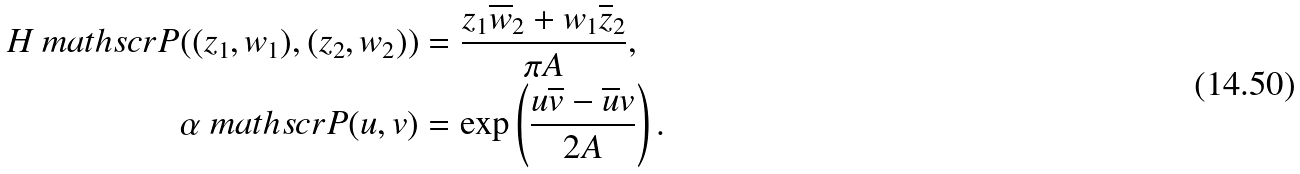<formula> <loc_0><loc_0><loc_500><loc_500>H _ { \ } m a t h s c r { P } ( ( z _ { 1 } , w _ { 1 } ) , ( z _ { 2 } , w _ { 2 } ) ) & = \frac { z _ { 1 } \overline { w } _ { 2 } + w _ { 1 } \overline { z } _ { 2 } } { \pi A } , \\ \alpha _ { \ } m a t h s c r { P } ( u , v ) & = \exp \left ( \frac { u \overline { v } - \overline { u } v } { 2 A } \right ) .</formula> 